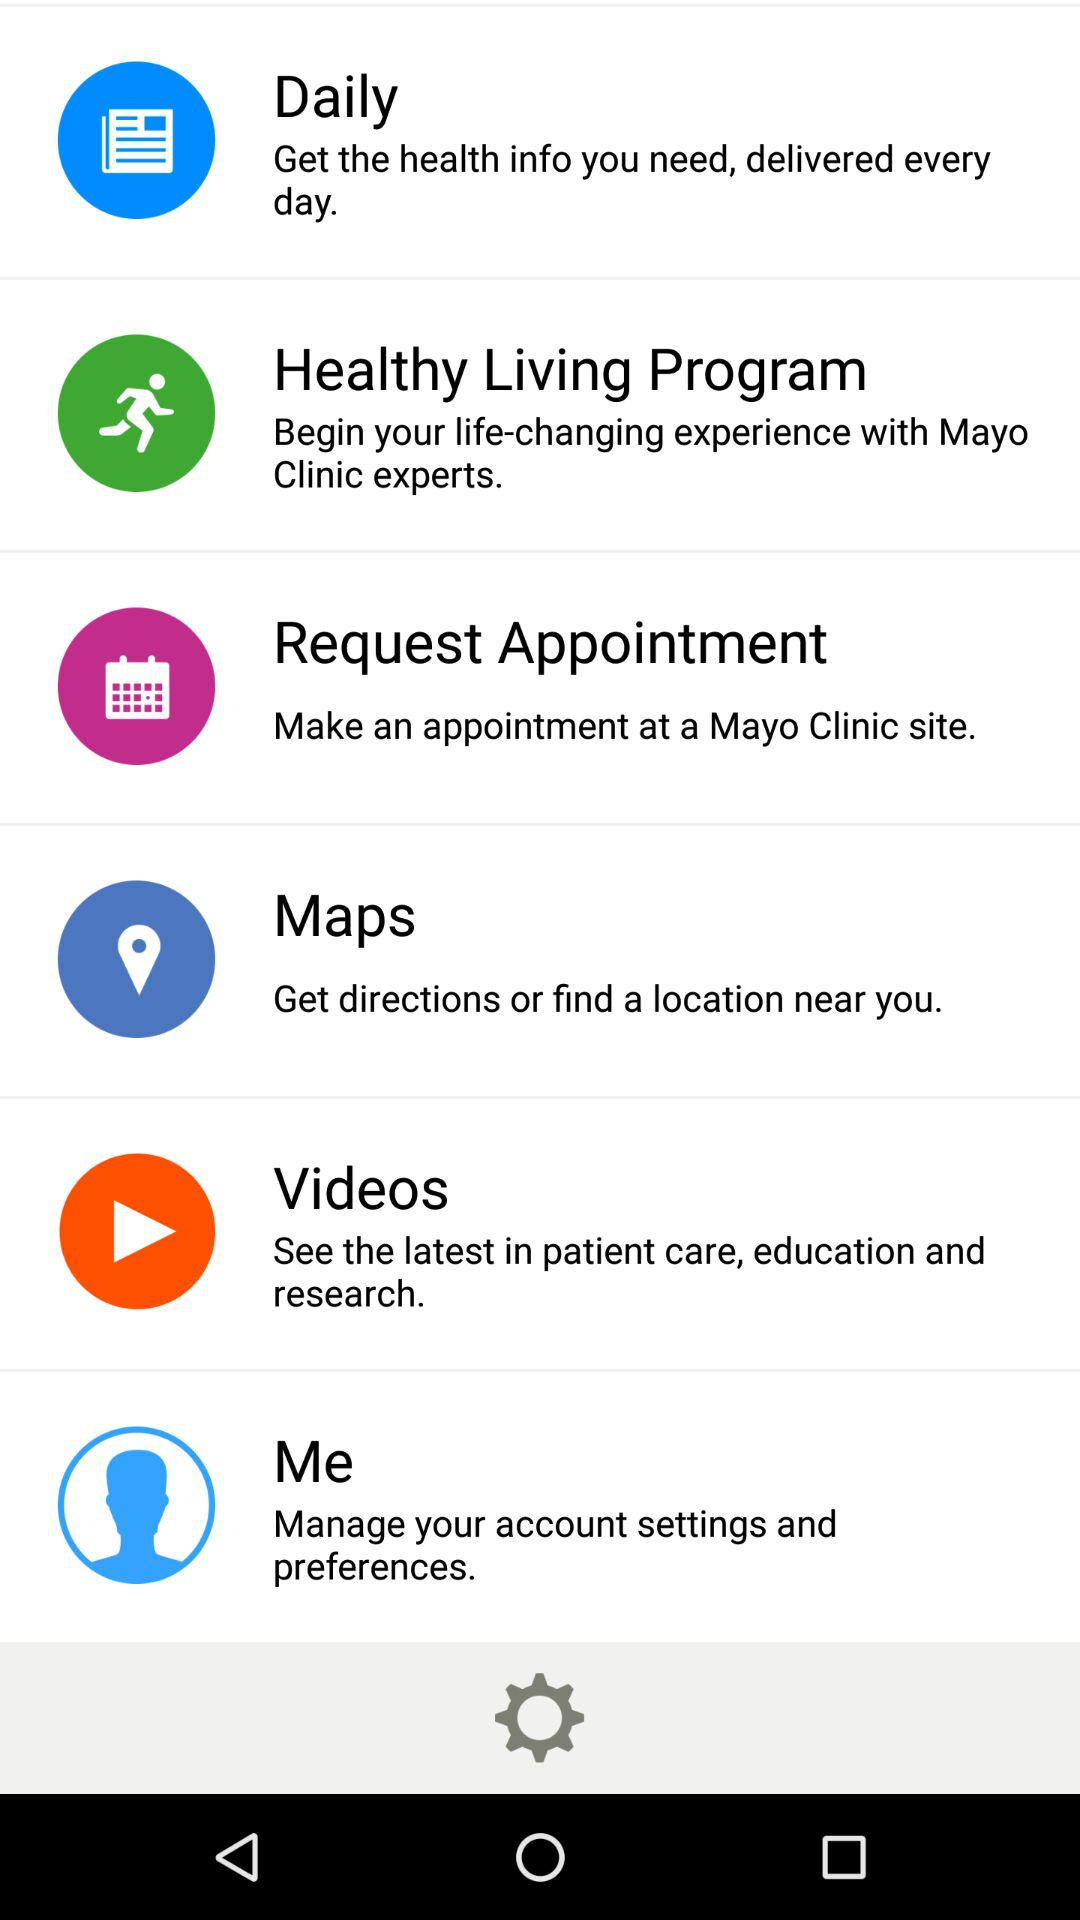What is the description given for the videos setting? The given description is "See the latest in patient care, education and research". 